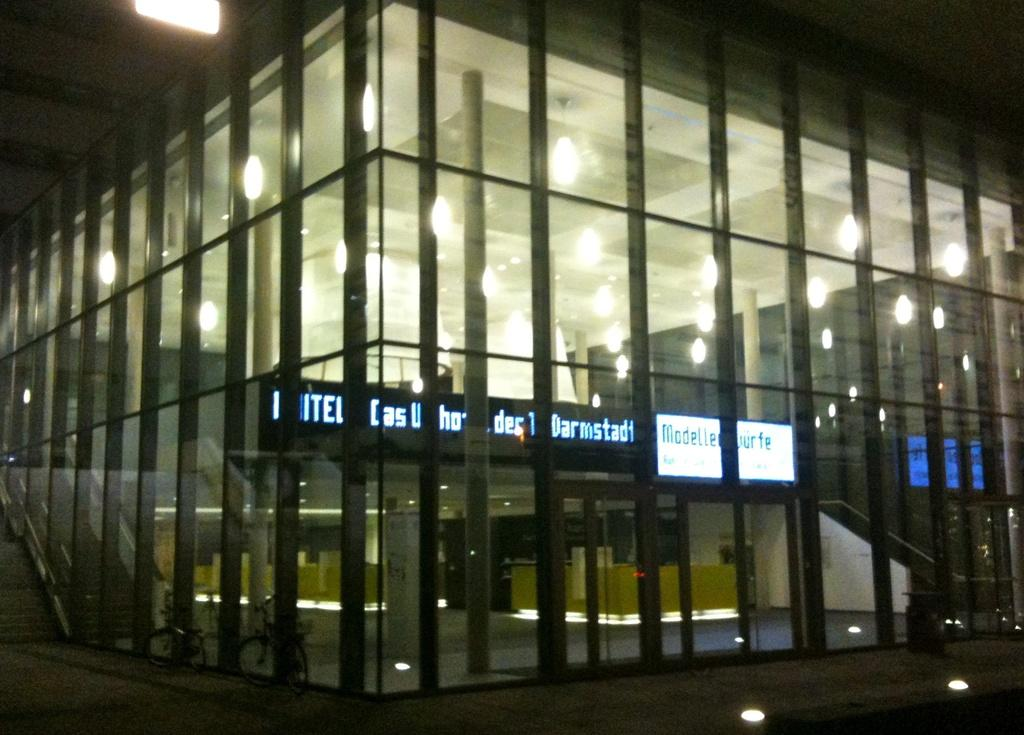What can be seen on the path in the image? There are bicycles on the path in the image. What can be seen illuminating the area in the image? There are lights visible in the image. What is written or displayed on the boards in the image? There is text on boards in the image. What can be seen inside the building in the image? There are objects visible in the building in the image. What type of meal is being prepared by the father in the image? There is no father or meal preparation present in the image. What type of approval is being sought in the image? There is no approval-seeking activity present in the image. 